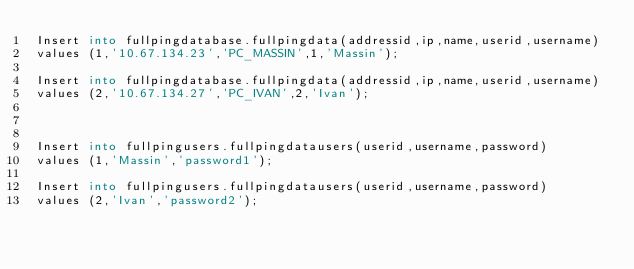<code> <loc_0><loc_0><loc_500><loc_500><_SQL_>Insert into fullpingdatabase.fullpingdata(addressid,ip,name,userid,username)
values (1,'10.67.134.23','PC_MASSIN',1,'Massin');

Insert into fullpingdatabase.fullpingdata(addressid,ip,name,userid,username)
values (2,'10.67.134.27','PC_IVAN',2,'Ivan');



Insert into fullpingusers.fullpingdatausers(userid,username,password)
values (1,'Massin','password1');

Insert into fullpingusers.fullpingdatausers(userid,username,password)
values (2,'Ivan','password2');</code> 